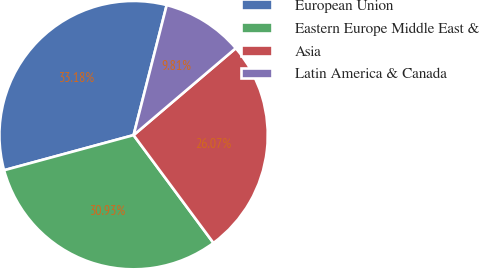Convert chart. <chart><loc_0><loc_0><loc_500><loc_500><pie_chart><fcel>European Union<fcel>Eastern Europe Middle East &<fcel>Asia<fcel>Latin America & Canada<nl><fcel>33.18%<fcel>30.93%<fcel>26.07%<fcel>9.81%<nl></chart> 